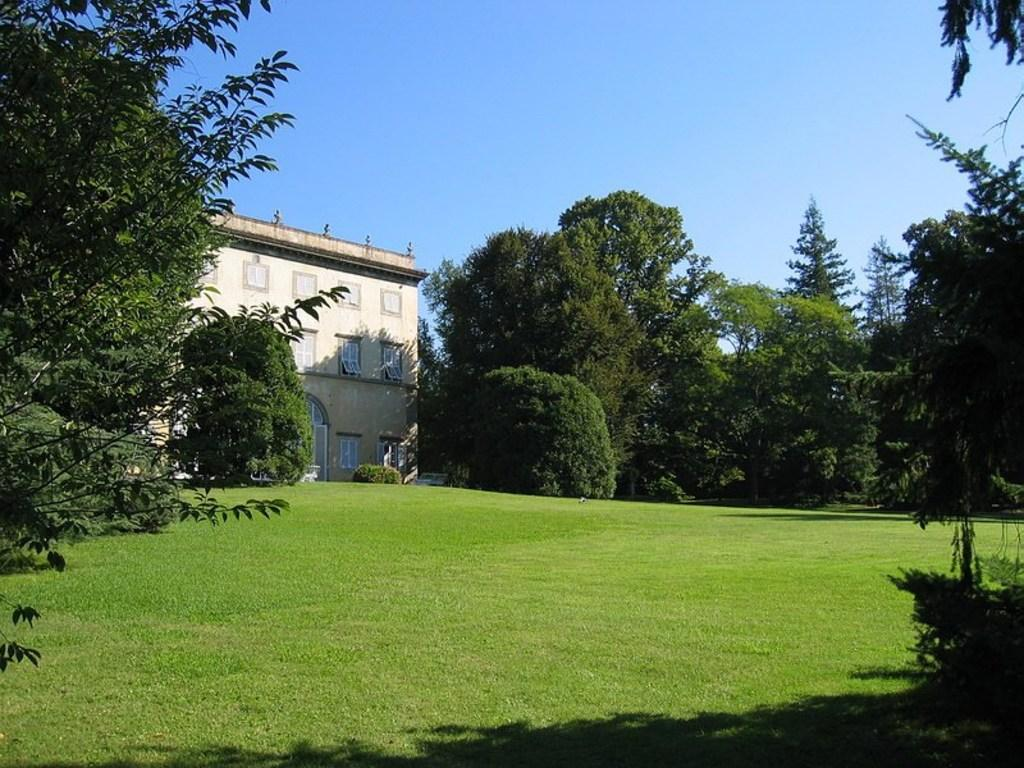What type of vegetation can be seen on both sides of the image? There are trees on both sides of the image. What structure is located in front of the trees? There is a building in front of the trees. What feature of the building is mentioned in the facts? The building has windows. What is the color of the sky in the image? The sky is blue in color. Can you describe the art created by the stranger in the image? There is no mention of a stranger or any art in the image. The image only features trees, a building, and a blue sky. 